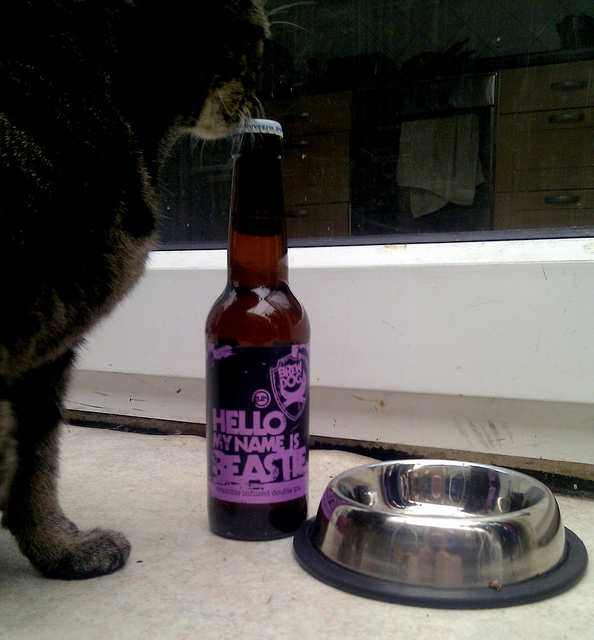Please transcribe the text in this image. HELLO NAME IS MY BEASTE DOG 